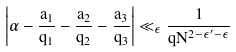Convert formula to latex. <formula><loc_0><loc_0><loc_500><loc_500>\left | \alpha - \frac { a _ { 1 } } { q _ { 1 } } - \frac { a _ { 2 } } { q _ { 2 } } - \frac { a _ { 3 } } { q _ { 3 } } \right | \ll _ { \epsilon } \frac { 1 } { q N ^ { 2 - \epsilon ^ { \prime } - \epsilon } }</formula> 